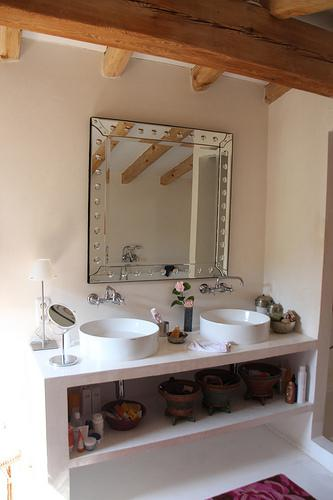Question: what color are the roses?
Choices:
A. Red.
B. Pink.
C. White.
D. Blue.
Answer with the letter. Answer: B Question: where was the picture taken?
Choices:
A. A bathroom.
B. Living room.
C. Kitchen.
D. Bedroom.
Answer with the letter. Answer: A 